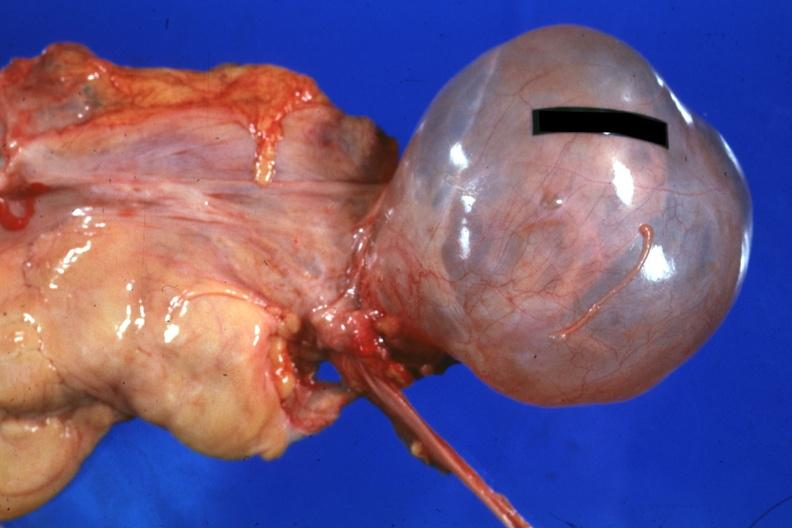what is present?
Answer the question using a single word or phrase. Serous cyst 